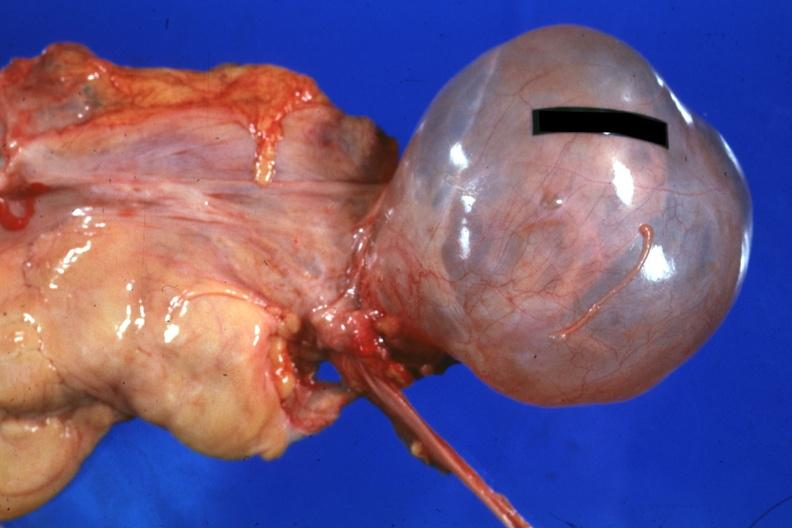what is present?
Answer the question using a single word or phrase. Serous cyst 